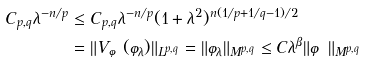Convert formula to latex. <formula><loc_0><loc_0><loc_500><loc_500>C _ { p , q } \lambda ^ { - n / p } & \leq C _ { p , q } \lambda ^ { - n / p } ( 1 + \lambda ^ { 2 } ) ^ { n ( 1 / p + 1 / q - 1 ) / 2 } \\ & = \| V _ { \varphi } ( \varphi _ { \lambda } ) \| _ { L ^ { p , q } } = \| \varphi _ { \lambda } \| _ { M ^ { p , q } } \leq C \lambda ^ { \beta } \| \varphi \| _ { M ^ { p , q } }</formula> 